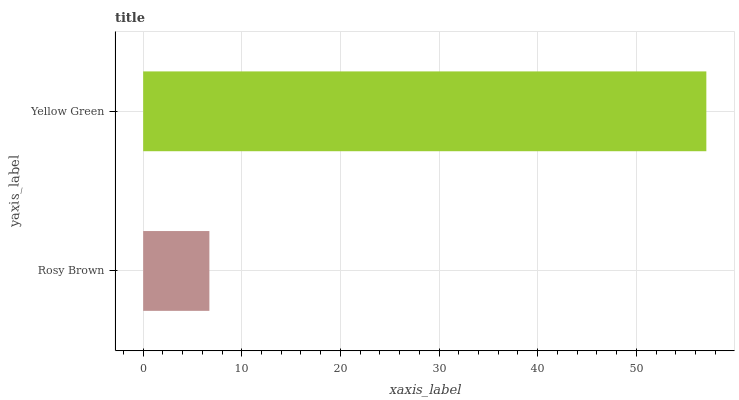Is Rosy Brown the minimum?
Answer yes or no. Yes. Is Yellow Green the maximum?
Answer yes or no. Yes. Is Yellow Green the minimum?
Answer yes or no. No. Is Yellow Green greater than Rosy Brown?
Answer yes or no. Yes. Is Rosy Brown less than Yellow Green?
Answer yes or no. Yes. Is Rosy Brown greater than Yellow Green?
Answer yes or no. No. Is Yellow Green less than Rosy Brown?
Answer yes or no. No. Is Yellow Green the high median?
Answer yes or no. Yes. Is Rosy Brown the low median?
Answer yes or no. Yes. Is Rosy Brown the high median?
Answer yes or no. No. Is Yellow Green the low median?
Answer yes or no. No. 